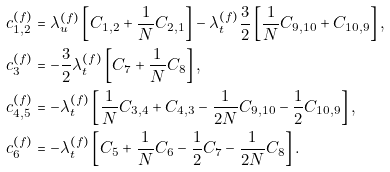Convert formula to latex. <formula><loc_0><loc_0><loc_500><loc_500>c _ { 1 , 2 } ^ { ( f ) } & = \lambda _ { u } ^ { ( f ) } \left [ C _ { 1 , 2 } + \frac { 1 } { N } C _ { 2 , 1 } \right ] - \lambda _ { t } ^ { ( f ) } \frac { 3 } { 2 } \left [ \frac { 1 } { N } C _ { 9 , 1 0 } + C _ { 1 0 , 9 } \right ] , \\ c _ { 3 } ^ { ( f ) } & = - \frac { 3 } { 2 } \lambda _ { t } ^ { ( f ) } \left [ C _ { 7 } + \frac { 1 } { N } C _ { 8 } \right ] , \\ c _ { 4 , 5 } ^ { ( f ) } & = - \lambda _ { t } ^ { ( f ) } \left [ \frac { 1 } { N } C _ { 3 , 4 } + C _ { 4 , 3 } - \frac { 1 } { 2 N } C _ { 9 , 1 0 } - \frac { 1 } { 2 } C _ { 1 0 , 9 } \right ] , \\ c _ { 6 } ^ { ( f ) } & = - \lambda _ { t } ^ { ( f ) } \left [ C _ { 5 } + \frac { 1 } { N } C _ { 6 } - \frac { 1 } { 2 } C _ { 7 } - \frac { 1 } { 2 N } C _ { 8 } \right ] .</formula> 